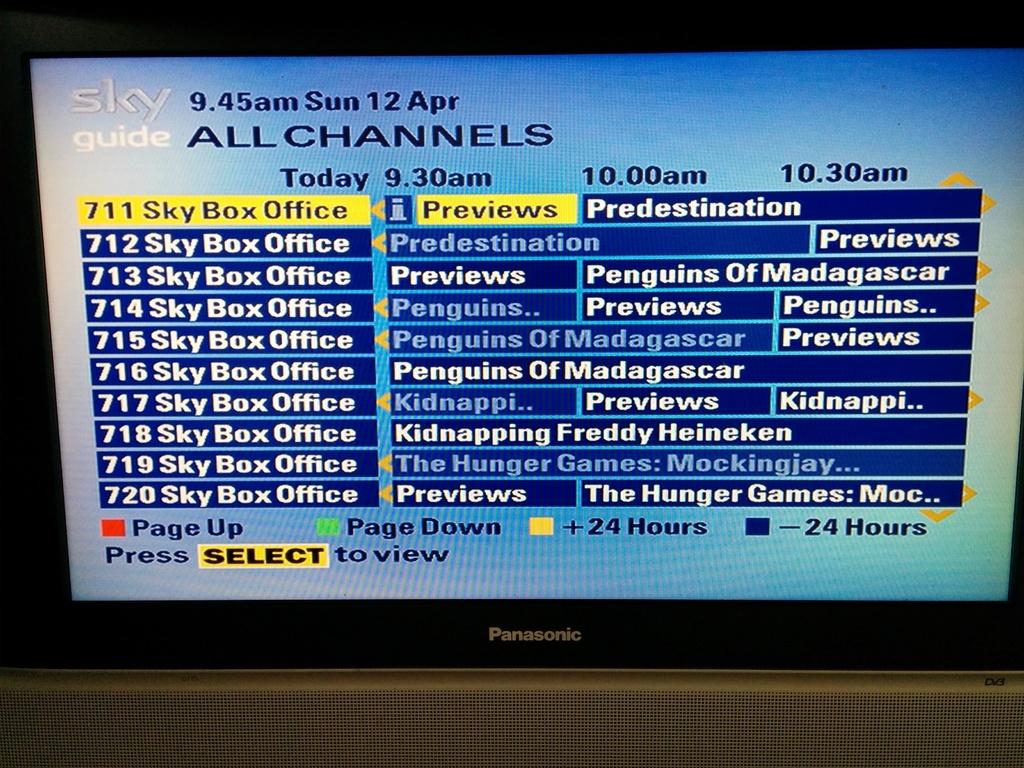What children's movie starts at 9:30am?
Make the answer very short. Penguins of madagascar. What is the date?
Keep it short and to the point. April 12. 